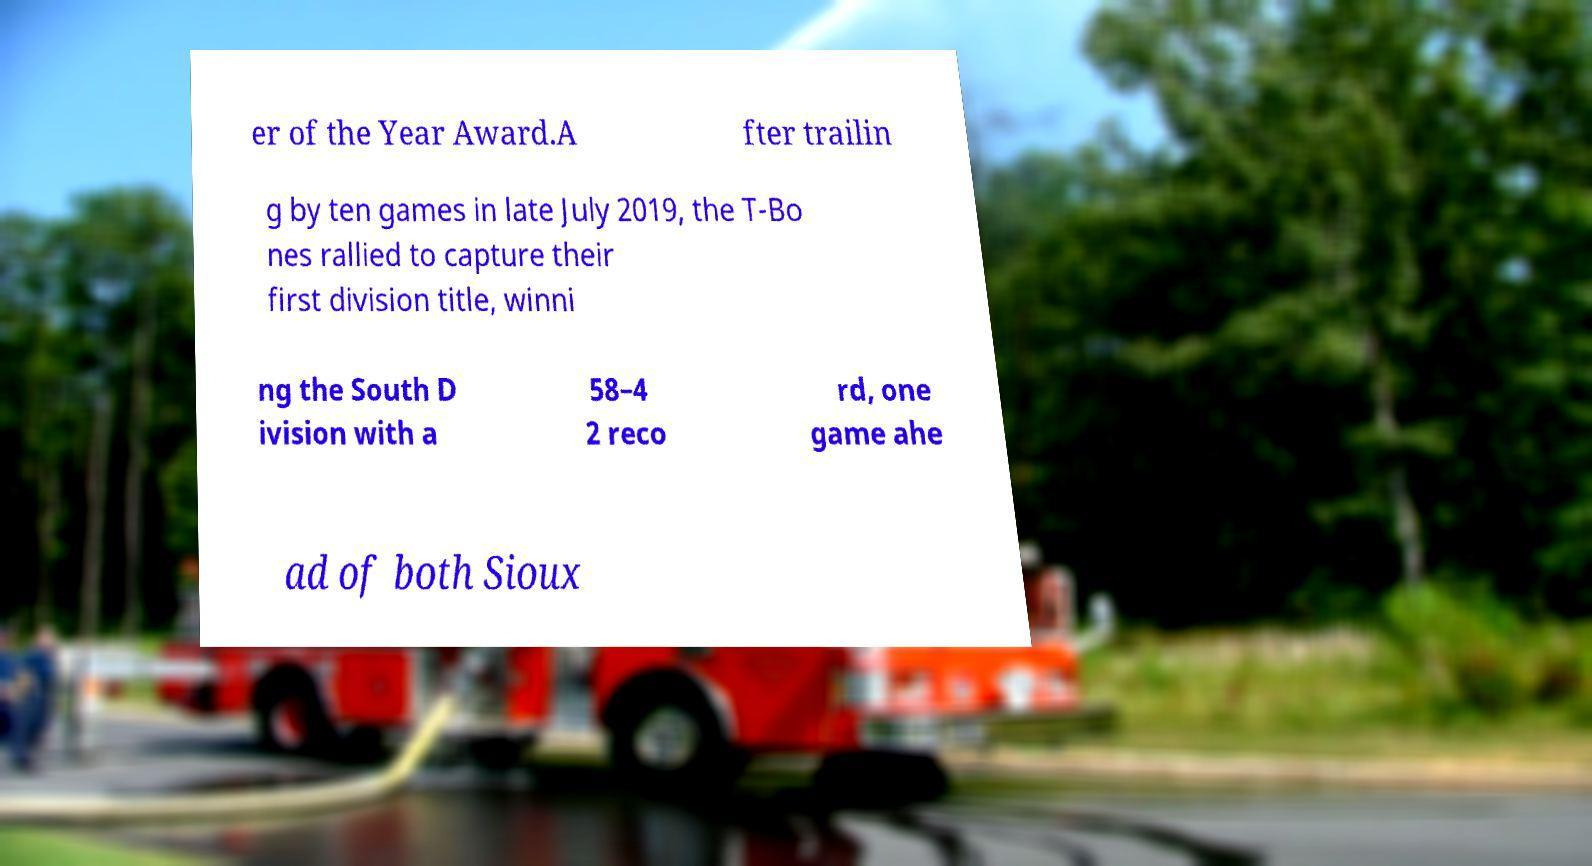I need the written content from this picture converted into text. Can you do that? er of the Year Award.A fter trailin g by ten games in late July 2019, the T-Bo nes rallied to capture their first division title, winni ng the South D ivision with a 58–4 2 reco rd, one game ahe ad of both Sioux 